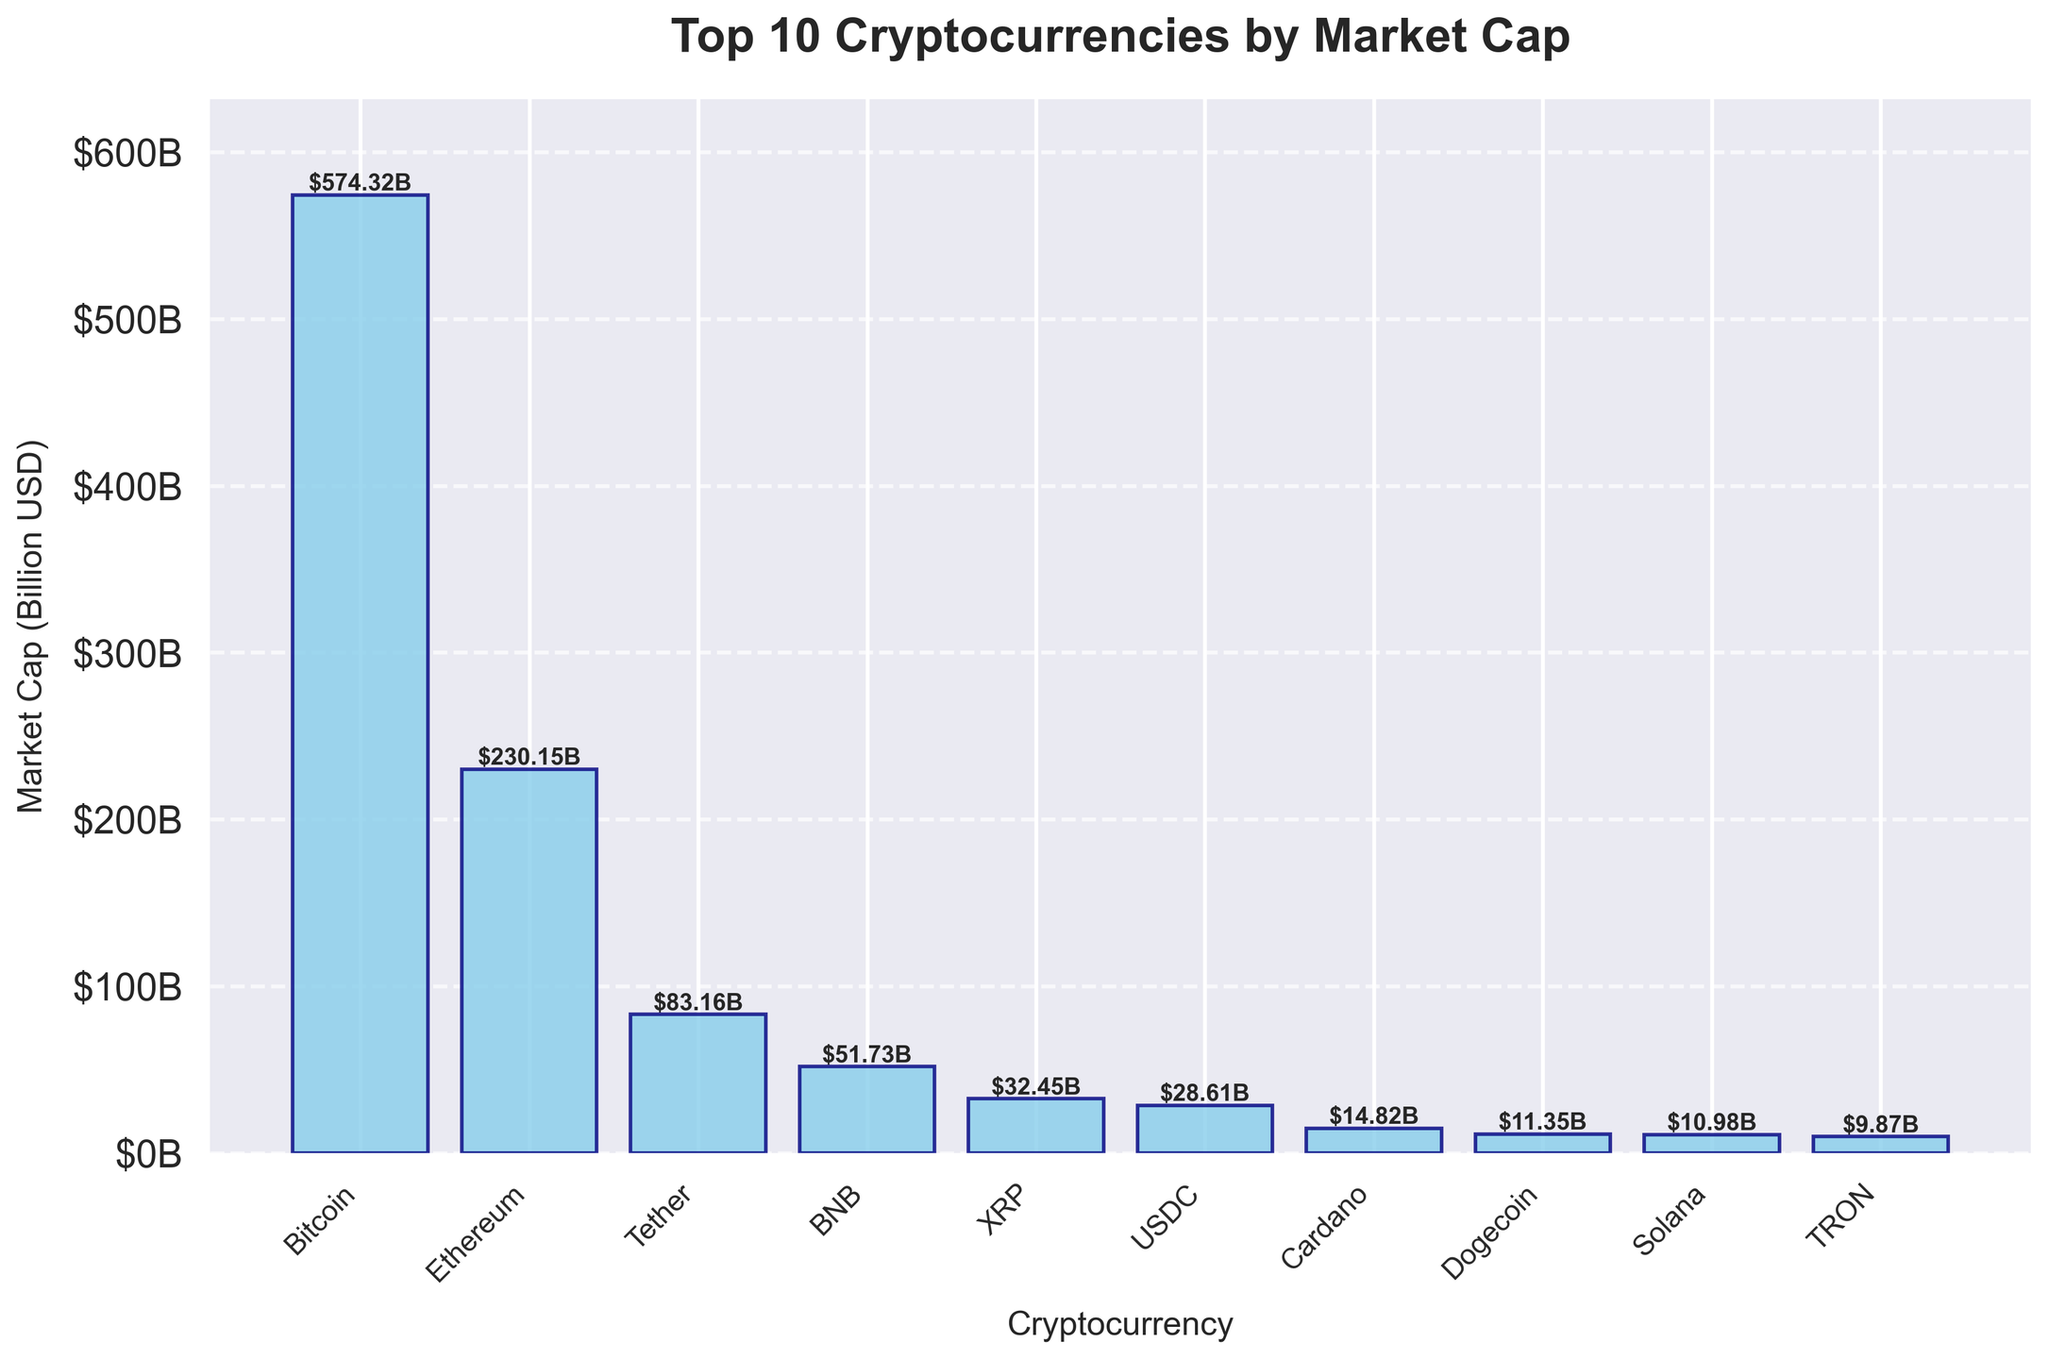What is the cryptocurrency with the highest market cap? The cryptocurrency with the highest market cap is the tallest bar in the bar chart. By identifying the tallest bar, we can see that Bitcoin has the highest market cap.
Answer: Bitcoin Which cryptocurrency has the lowest market cap among the top 10? The cryptocurrency with the lowest market cap will be represented by the shortest bar in the figure. By examining the chart, Tron has the shortest bar among the top 10 cryptocurrencies.
Answer: TRON How much more market cap does Bitcoin have compared to Ethereum? To find how much more market cap Bitcoin has compared to Ethereum, subtract Ethereum's market cap from Bitcoin's market cap. From the chart, Bitcoin's market cap is $574.32 billion, and Ethereum's market cap is $230.15 billion. The difference is $574.32B - $230.15B.
Answer: $344.17B What are the total market caps of Tether, BNB, and XRP combined? Sum the market caps of Tether, BNB, and XRP. According to the bar chart, Tether's market cap is $83.16 billion, BNB's market cap is $51.73 billion, and XRP's market cap is $32.45 billion. So, the total is $83.16B + $51.73B + $32.45B.
Answer: $167.34B Which two cryptocurrencies have market caps closest in value? To identify the two cryptocurrencies with the closest market caps, compare the heights of the bars. By observation, Dogecoin and Solana have market caps that are very close in value, with values of $11.35B and $10.98B, respectively.
Answer: Dogecoin and Solana Is the market cap of USDC greater or less than half of Bitcoin's market cap? To determine if the market cap of USDC is greater or less than half of Bitcoin's market cap, first find half of Bitcoin's market cap. Bitcoin's market cap is $574.32 billion, so half of it is $574.32B / 2 = $287.16B. USDC's market cap is $28.61 billion, which is less than $287.16 billion.
Answer: Less Which cryptocurrencies have a market cap that is greater than $50 billion? To find cryptocurrencies with a market cap greater than $50 billion, identify bars taller than the $50B mark. Bitcoin, Ethereum, Tether, and BNB have market caps greater than $50 billion.
Answer: Bitcoin, Ethereum, Tether, and BNB Between Ethereum and Tether, which one has a higher market cap and by how much? Compare the market caps of Ethereum and Tether by subtracting Tether's market cap from Ethereum's market cap. Ethereum's market cap is $230.15 billion, and Tether's market cap is $83.16 billion. The difference is $230.15B - $83.16B.
Answer: Ethereum, by $146.99B What proportion of the total market cap of the top 10 is held by Bitcoin? First, find the total market cap of the top 10 cryptocurrencies by summing their market caps. Then, divide Bitcoin's market cap by this total. The total market cap is $574.32B + $230.15B + $83.16B + $51.73B + $32.45B + $28.61B + $14.82B + $11.35B + $10.98B + $9.87B = $1,047.44B. The proportion is $574.32B / $1,047.44B.
Answer: 0.548 or 54.8% What is the average market cap of the top 10 cryptocurrencies? Calculate the sum of the market caps of the top 10 cryptocurrencies and divide by 10. The total market cap for the top 10 is $1,047.44B. Thus, the average is $1,047.44B / 10.
Answer: $104.74B 